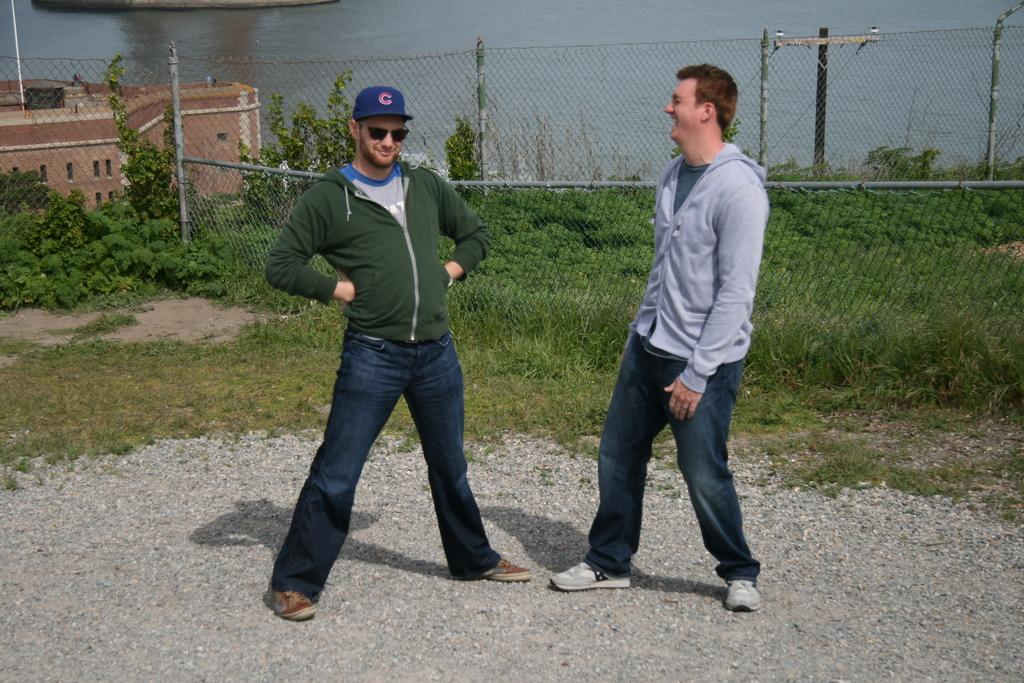How many people are present in the image? There are two people in the image. What can be seen in the background of the image? In the background, there are plants, a fence, grass, a building with windows, and water. Can you describe the setting of the image? The image appears to be set in an outdoor area with a mix of natural and man-made elements. What type of cakes are being served at the property in the image? There is no mention of cakes or a property in the image; it features two people and various background elements. 